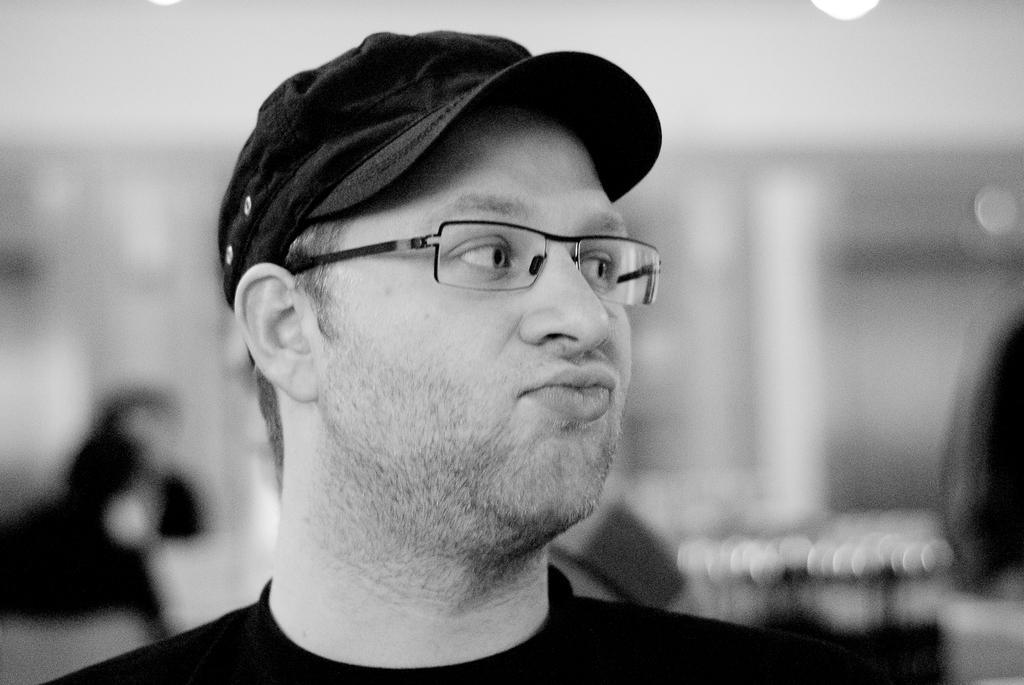In one or two sentences, can you explain what this image depicts? In this black and white picture there is a man. The background is blurry. 